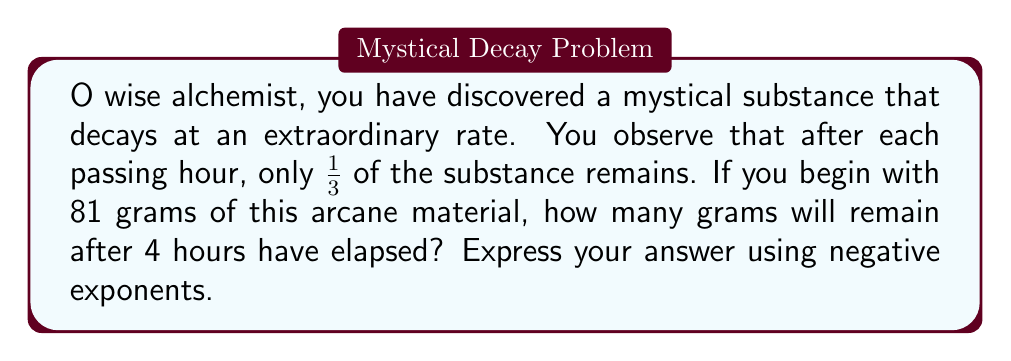Can you answer this question? Let us unravel this mystical conundrum step by step:

1) First, we must understand the decay rate. After each hour, $\frac{1}{3}$ of the substance remains. This can be expressed as a multiplier of $(\frac{1}{3})$ for each hour.

2) For 4 hours, we must apply this multiplier 4 times. Mathematically, this is equivalent to raising $(\frac{1}{3})$ to the 4th power:

   $(\frac{1}{3})^4$

3) Now, we can rewrite this using the properties of exponents:

   $(\frac{1}{3})^4 = 3^{-4}$

4) To find the amount remaining, we multiply the initial amount by this factor:

   $81 \cdot 3^{-4}$

5) We can simplify this further:
   
   $81 = 3^4$
   
   So our expression becomes:

   $3^4 \cdot 3^{-4} = 3^{4-4} = 3^0 = 1$

Therefore, after 4 hours, 1 gram of the substance will remain.
Answer: $1$ gram, or $81 \cdot 3^{-4}$ grams 